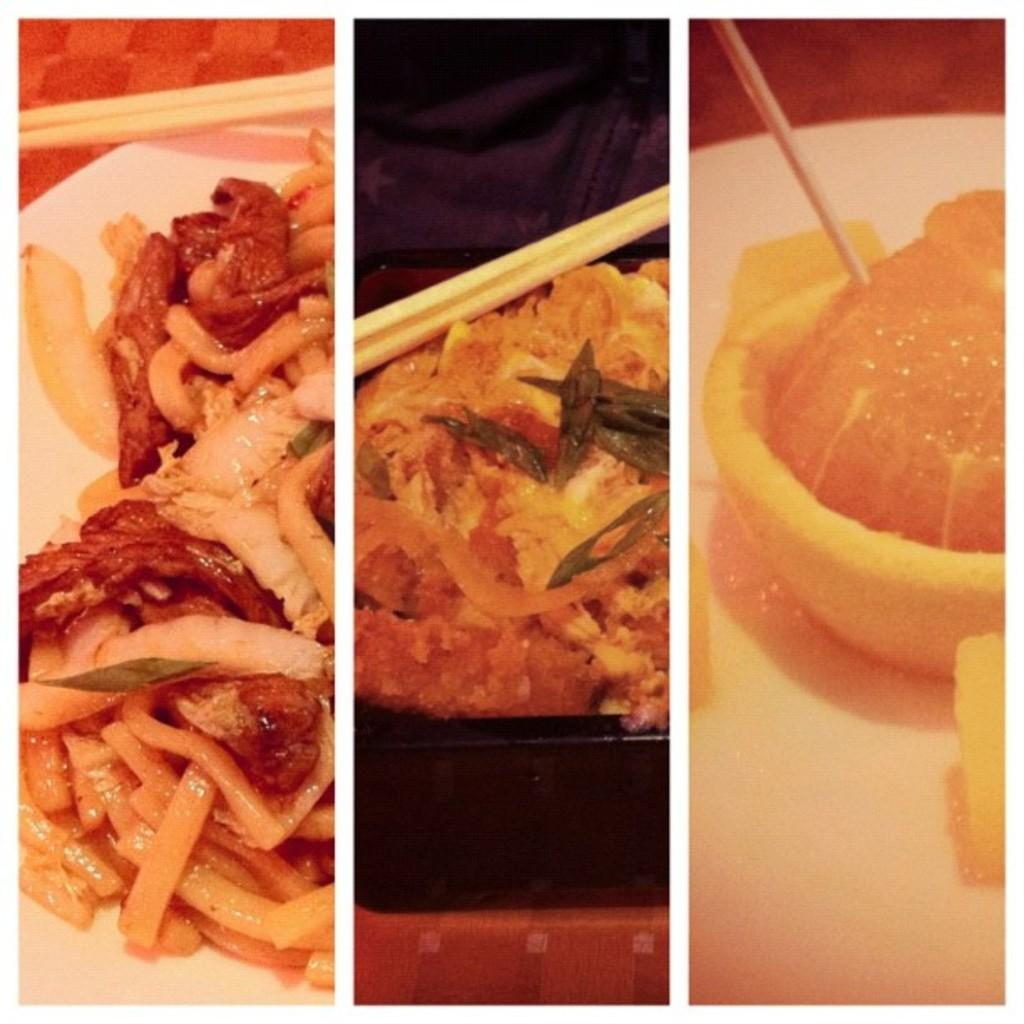What type of artwork is depicted in the image? The image is a collage. What can be seen in the collage? There are food items in the image. What color are the plates on which the food items are placed? The food items are on white color plates. Can you tell me how many sea creatures are swimming in the image? There are no sea creatures present in the image; it is a collage of food items on white plates. What type of calculator is visible in the image? There is no calculator present in the image. 